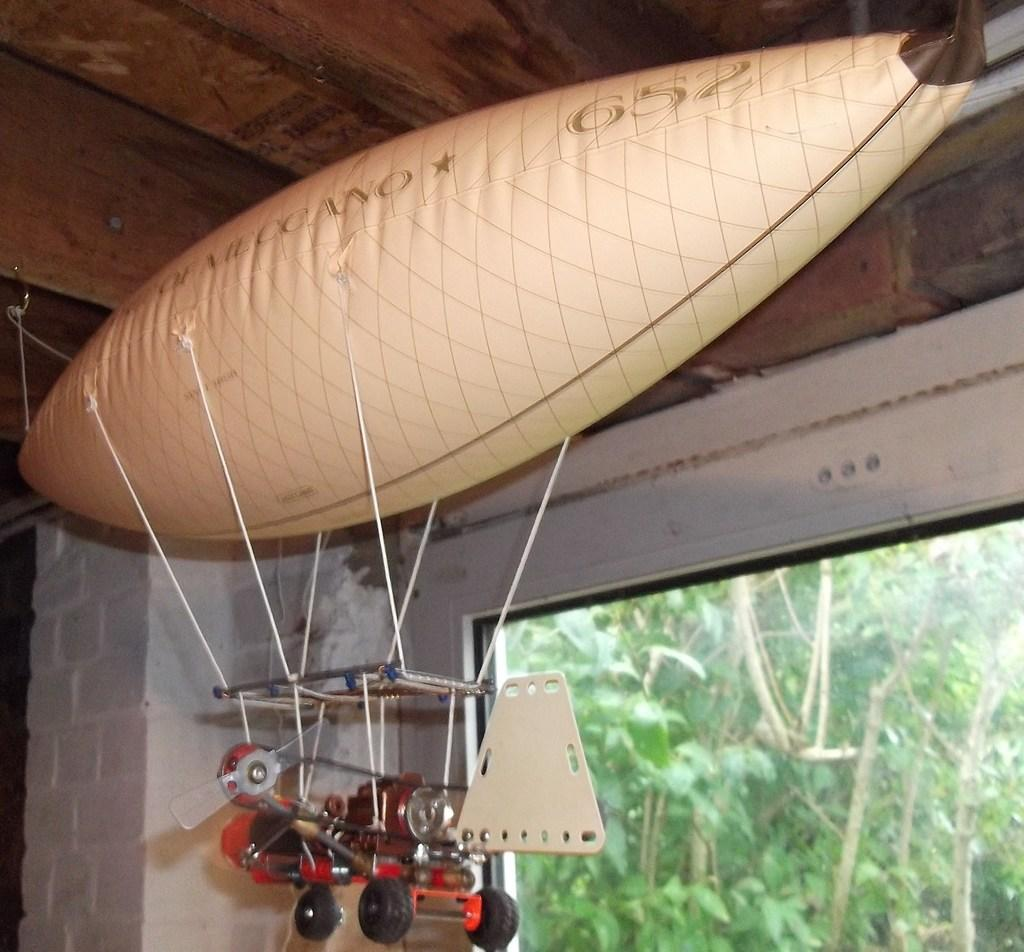What is the color of the air balloon in the image? The air balloon in the image is cream-colored. What other object can be seen in the image besides the air balloon? There is a red-colored toy in the image. What can be seen in the background of the image? There are trees in the background of the image. Is there any text or writing visible in the image? Yes, there is text or writing visible in the image. What type of lettuce is being used as a tongue for the red-colored toy in the image? There is no lettuce or tongue present in the image; it features a cream-colored air balloon and a red-colored toy. 